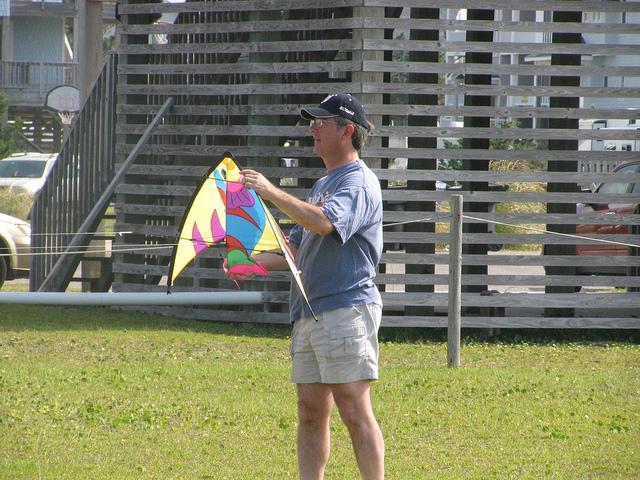How many cars are in the picture?
Give a very brief answer. 2. How many dogs are sleeping?
Give a very brief answer. 0. 